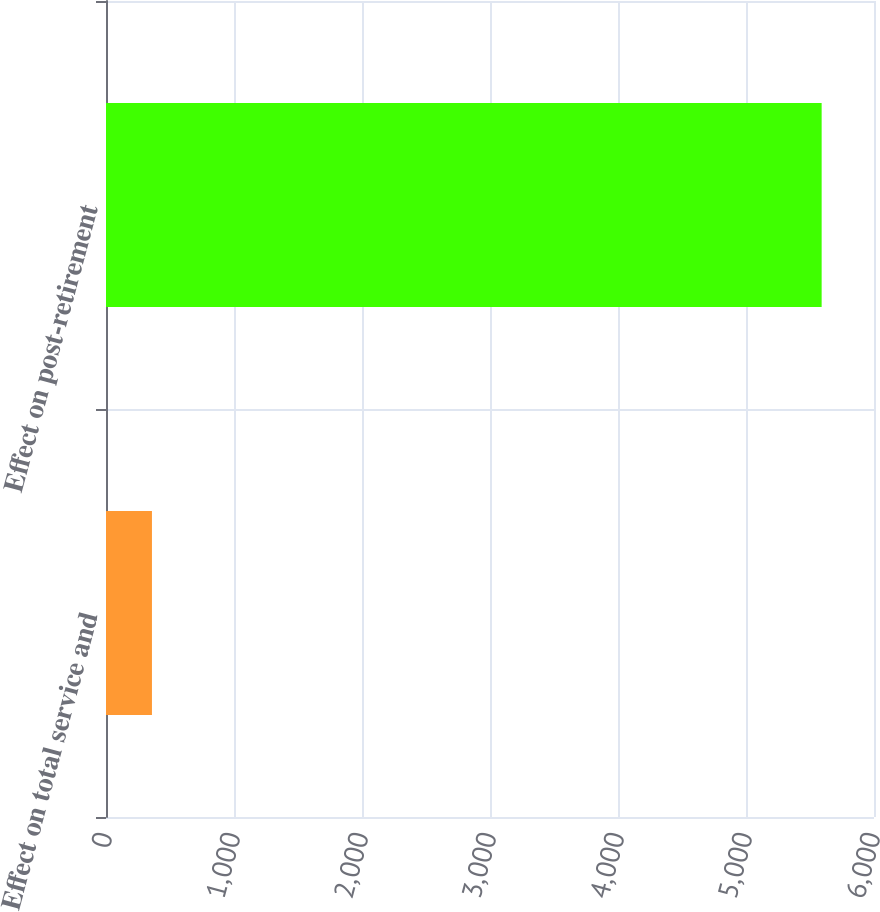<chart> <loc_0><loc_0><loc_500><loc_500><bar_chart><fcel>Effect on total service and<fcel>Effect on post-retirement<nl><fcel>359<fcel>5591<nl></chart> 